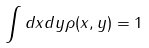Convert formula to latex. <formula><loc_0><loc_0><loc_500><loc_500>\int d x d y \rho ( x , y ) = 1</formula> 